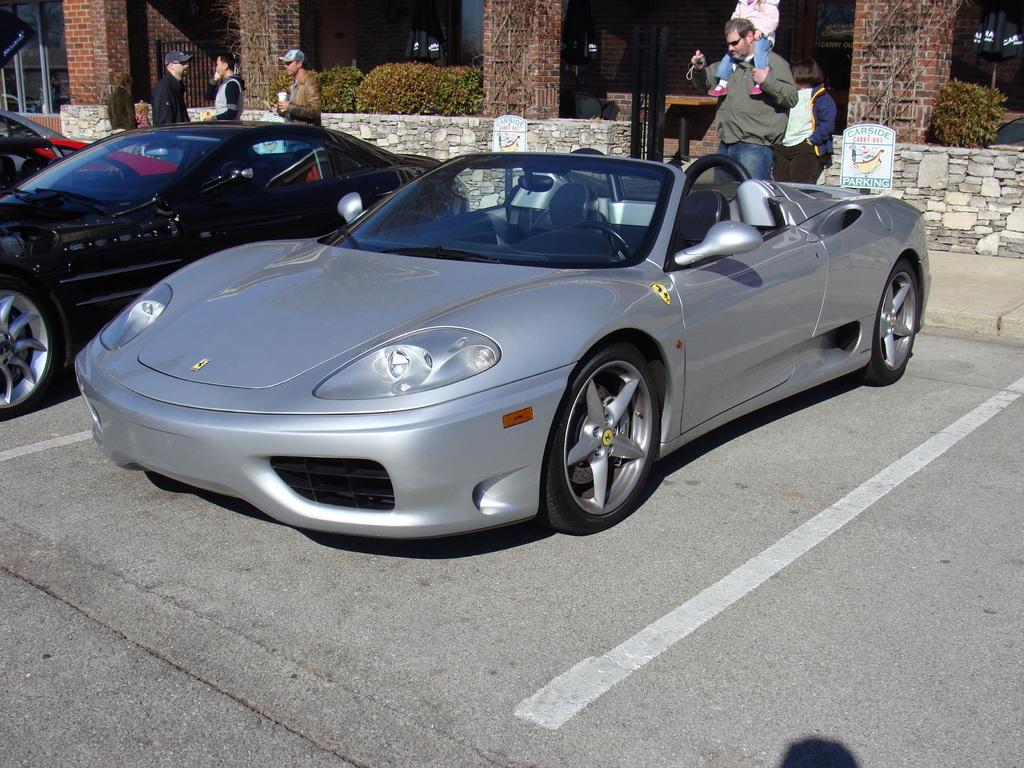How would you summarize this image in a sentence or two? In the image I can see cars which are black and grey in color. In the background I can see people among them some are holding objects in hands and the man on the right side is carrying a child on his shoulder. I can also see plants, pillars and some other objects. 